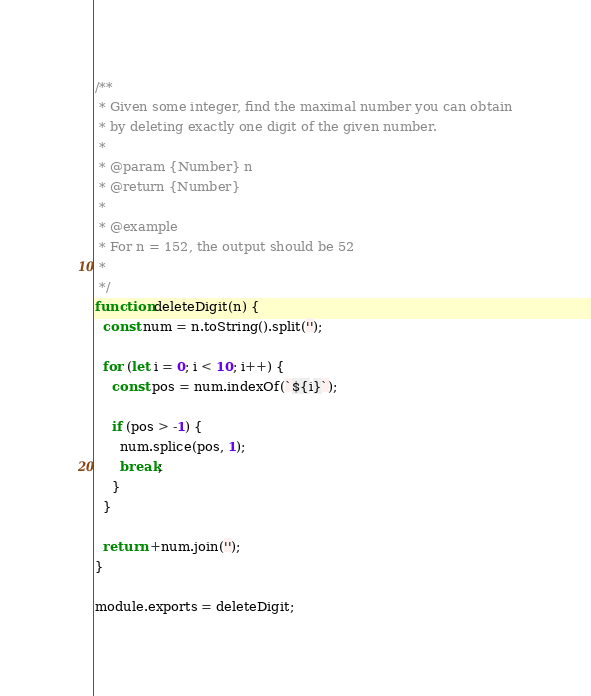Convert code to text. <code><loc_0><loc_0><loc_500><loc_500><_JavaScript_>/**
 * Given some integer, find the maximal number you can obtain
 * by deleting exactly one digit of the given number.
 *
 * @param {Number} n
 * @return {Number}
 *
 * @example
 * For n = 152, the output should be 52
 *
 */
function deleteDigit(n) {
  const num = n.toString().split('');

  for (let i = 0; i < 10; i++) {
    const pos = num.indexOf(`${i}`);

    if (pos > -1) {
      num.splice(pos, 1);
      break;
    }
  }

  return +num.join('');
}

module.exports = deleteDigit;
</code> 